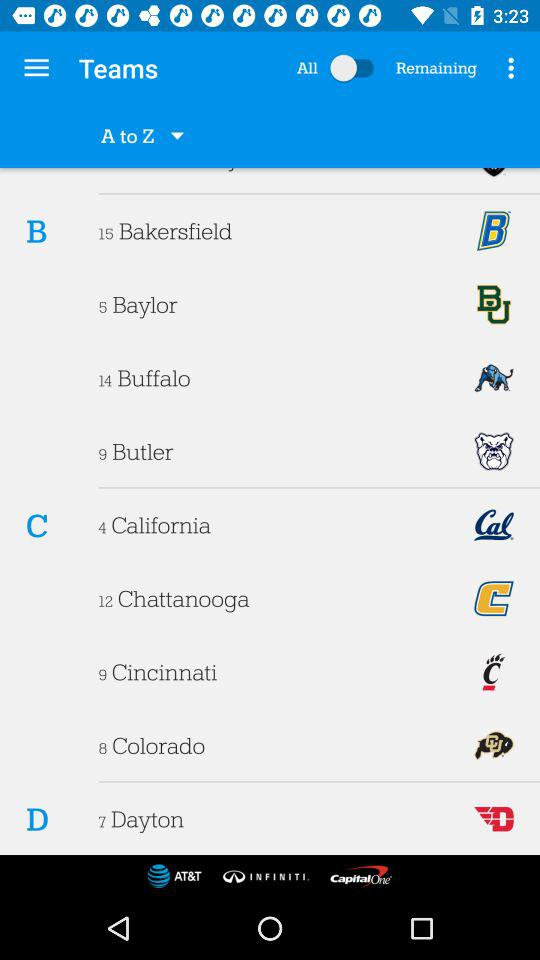How many are remaining?
When the provided information is insufficient, respond with <no answer>. <no answer> 